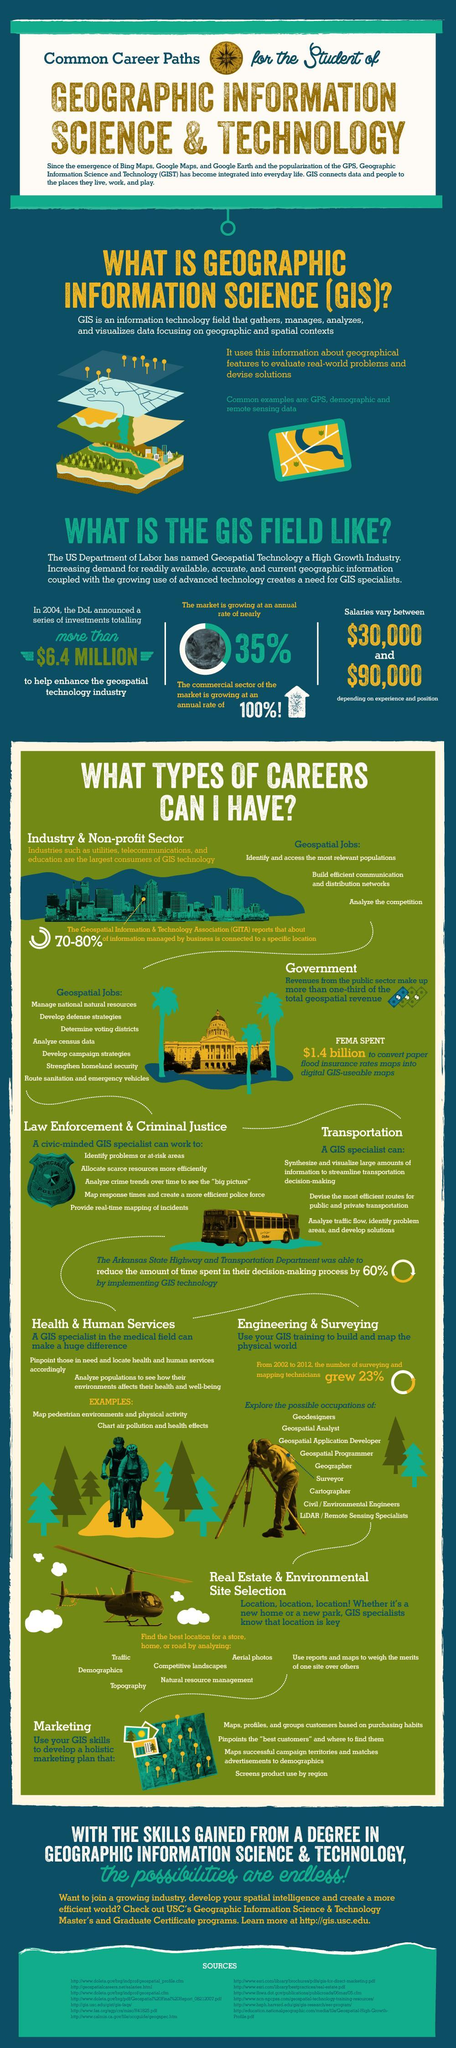What is the second function that can be performed by a GIS specialist working in Law & Justice sector?
Answer the question with a short phrase. Allocate scarce resources more efficiently GPS and remote sensing are examples of what? Geographic information science What is the maximum amount mentioned in the range of salaries drawn by GIS specialists? $90,000 A GIS specialist working in which sector provides real-time mapping of incidents? Law enforcement & Criminal justice In which field can GIS training be used to build and map the physical world? Engineering & Surveying In which sector can a GIS Specialist analyze traffic flow, identify problem areas and develop solutions? Transportation What was the investment amount announced by the DoL for geospatial industry? $6.4 million In which sector does a GIS specialist analyze census data? Government In which sector does a a GIS specialist chart air pollution and health effects? Health & Human Services A GIS specialist working in which field screens product use by region? Marketing 